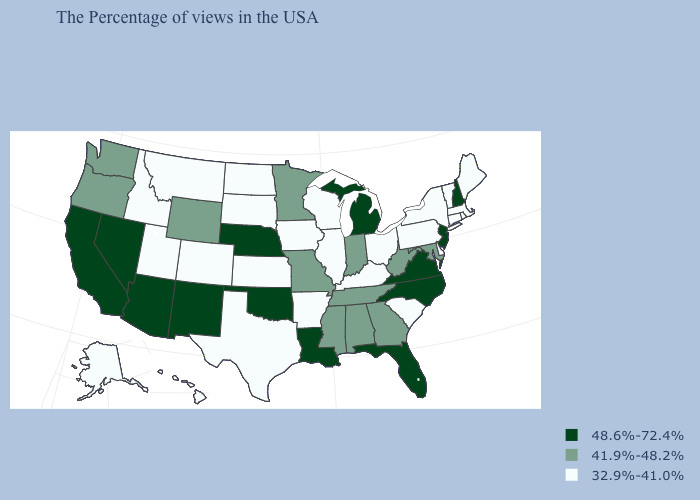Which states have the lowest value in the USA?
Concise answer only. Maine, Massachusetts, Rhode Island, Vermont, Connecticut, New York, Delaware, Pennsylvania, South Carolina, Ohio, Kentucky, Wisconsin, Illinois, Arkansas, Iowa, Kansas, Texas, South Dakota, North Dakota, Colorado, Utah, Montana, Idaho, Alaska, Hawaii. Among the states that border Montana , which have the lowest value?
Be succinct. South Dakota, North Dakota, Idaho. What is the lowest value in the MidWest?
Keep it brief. 32.9%-41.0%. Name the states that have a value in the range 41.9%-48.2%?
Keep it brief. Maryland, West Virginia, Georgia, Indiana, Alabama, Tennessee, Mississippi, Missouri, Minnesota, Wyoming, Washington, Oregon. What is the highest value in the USA?
Answer briefly. 48.6%-72.4%. Name the states that have a value in the range 48.6%-72.4%?
Concise answer only. New Hampshire, New Jersey, Virginia, North Carolina, Florida, Michigan, Louisiana, Nebraska, Oklahoma, New Mexico, Arizona, Nevada, California. What is the lowest value in states that border Wisconsin?
Quick response, please. 32.9%-41.0%. What is the lowest value in the Northeast?
Write a very short answer. 32.9%-41.0%. Name the states that have a value in the range 48.6%-72.4%?
Concise answer only. New Hampshire, New Jersey, Virginia, North Carolina, Florida, Michigan, Louisiana, Nebraska, Oklahoma, New Mexico, Arizona, Nevada, California. What is the value of Colorado?
Give a very brief answer. 32.9%-41.0%. Does the map have missing data?
Keep it brief. No. Among the states that border West Virginia , which have the highest value?
Answer briefly. Virginia. Name the states that have a value in the range 32.9%-41.0%?
Quick response, please. Maine, Massachusetts, Rhode Island, Vermont, Connecticut, New York, Delaware, Pennsylvania, South Carolina, Ohio, Kentucky, Wisconsin, Illinois, Arkansas, Iowa, Kansas, Texas, South Dakota, North Dakota, Colorado, Utah, Montana, Idaho, Alaska, Hawaii. Name the states that have a value in the range 41.9%-48.2%?
Give a very brief answer. Maryland, West Virginia, Georgia, Indiana, Alabama, Tennessee, Mississippi, Missouri, Minnesota, Wyoming, Washington, Oregon. 